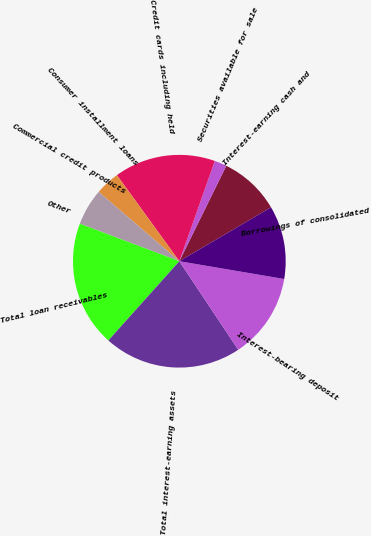Convert chart to OTSL. <chart><loc_0><loc_0><loc_500><loc_500><pie_chart><fcel>Interest-earning cash and<fcel>Securities available for sale<fcel>Credit cards including held<fcel>Consumer installment loans<fcel>Commercial credit products<fcel>Other<fcel>Total loan receivables<fcel>Total interest-earning assets<fcel>Interest-bearing deposit<fcel>Borrowings of consolidated<nl><fcel>9.27%<fcel>1.86%<fcel>15.4%<fcel>3.71%<fcel>5.57%<fcel>0.0%<fcel>19.11%<fcel>20.97%<fcel>12.98%<fcel>11.13%<nl></chart> 